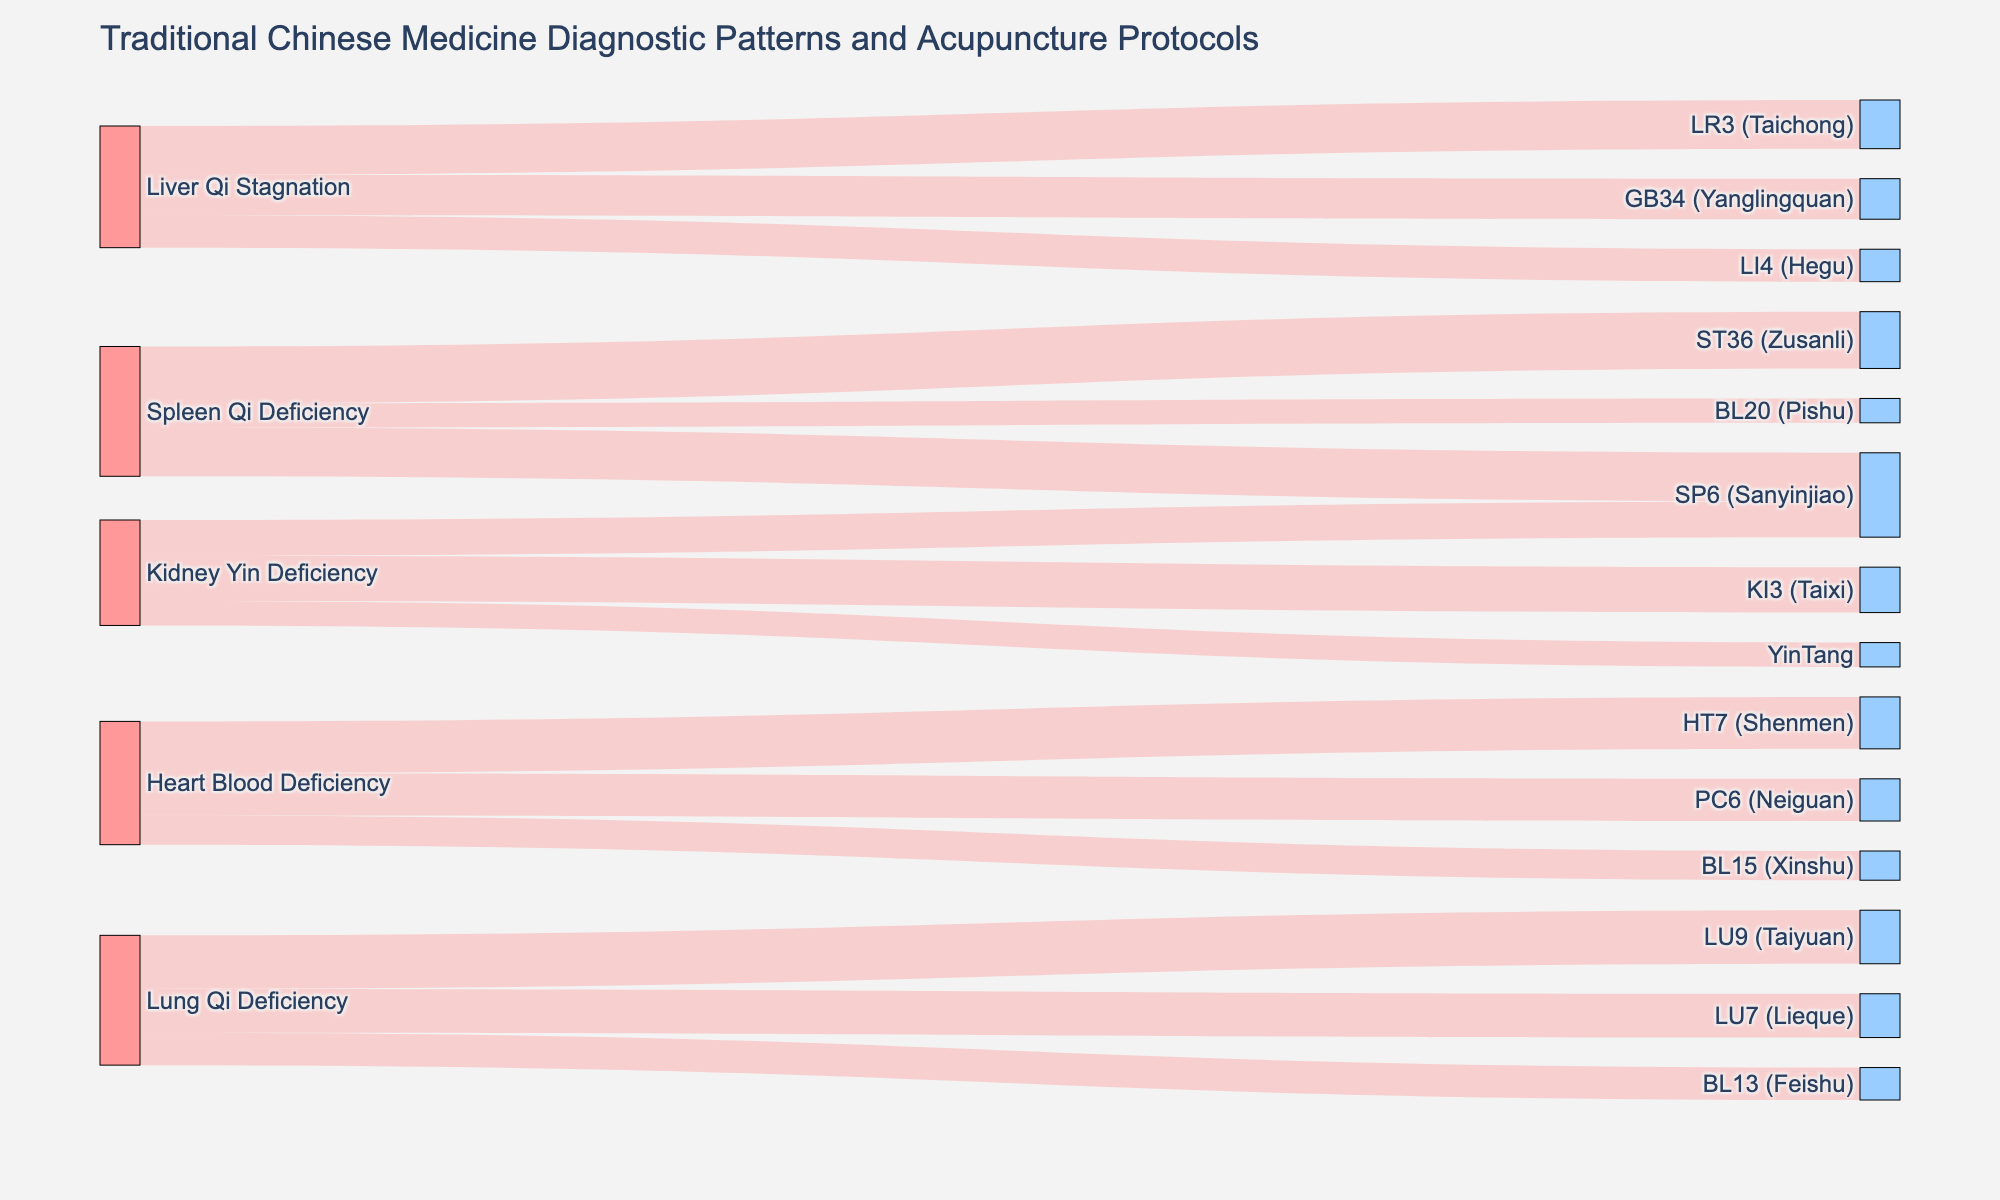What is the title of the figure? The title is located at the top of the diagram and provides an overview of the content presented. The title is "Traditional Chinese Medicine Diagnostic Patterns and Acupuncture Protocols".
Answer: Traditional Chinese Medicine Diagnostic Patterns and Acupuncture Protocols Which diagnostic pattern connects to the acupuncture point LR3 (Taichong)? To find this information, observe the link from the source 'Liver Qi Stagnation' to the target 'LR3 (Taichong)'.
Answer: Liver Qi Stagnation Which acupuncture point is targeted by both 'Spleen Qi Deficiency' and 'Kidney Yin Deficiency'? Look for targets that have links from both 'Spleen Qi Deficiency' and 'Kidney Yin Deficiency'. 'SP6 (Sanyinjiao)' is targeted by both.
Answer: SP6 (Sanyinjiao) Compare the values between the acupuncture points 'LU9 (Taiyuan)' and 'LU7 (Lieque)' for 'Lung Qi Deficiency'. Which one has the higher value? Look at the values for the links from 'Lung Qi Deficiency' to 'LU9 (Taiyuan)' and 'LU7 (Lieque)'. The value for LU9 (Taiyuan) is 33, and for LU7 (Lieque) is 27.
Answer: LU9 (Taiyuan) What is the smallest value among all links originating from 'Liver Qi Stagnation'? Identify the values connected to 'Liver Qi Stagnation', which are 30, 25, and 20; the smallest value is 20.
Answer: 20 How many acupuncture points are related to 'Kidney Yin Deficiency'? Count the number of unique targets linked from 'Kidney Yin Deficiency'. These targets are 'KI3 (Taixi)', 'SP6 (Sanyinjiao)', and 'YinTang'.
Answer: 3 What is the average value of the links associated with 'Spleen Qi Deficiency'? First, find the values of the links, which are 35, 30, and 15. Add these values and then divide by the number of links. (35 + 30 + 15) / 3 = 80 / 3 ~ 26.67
Answer: 26.67 Which diagnostic pattern has the most links to acupuncture points? By counting the number of links from each diagnostic pattern, 'Spleen Qi Deficiency' and 'Lung Qi Deficiency' both have three links, which is the maximum.
Answer: Spleen Qi Deficiency and Lung Qi Deficiency What is the total combined value of all the links in the diagram? Sum all the values in the diagram. The values are 30, 25, 20, 35, 30, 15, 28, 22, 15, 32, 26, 18, 33, 27, 20. The total is 376.
Answer: 376 